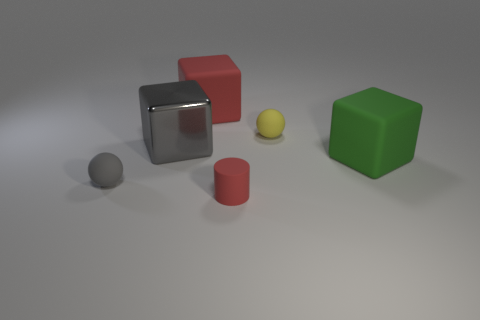Add 1 small yellow rubber blocks. How many objects exist? 7 Subtract all balls. How many objects are left? 4 Add 2 tiny balls. How many tiny balls are left? 4 Add 5 gray metallic blocks. How many gray metallic blocks exist? 6 Subtract 0 brown balls. How many objects are left? 6 Subtract all tiny red things. Subtract all large red blocks. How many objects are left? 4 